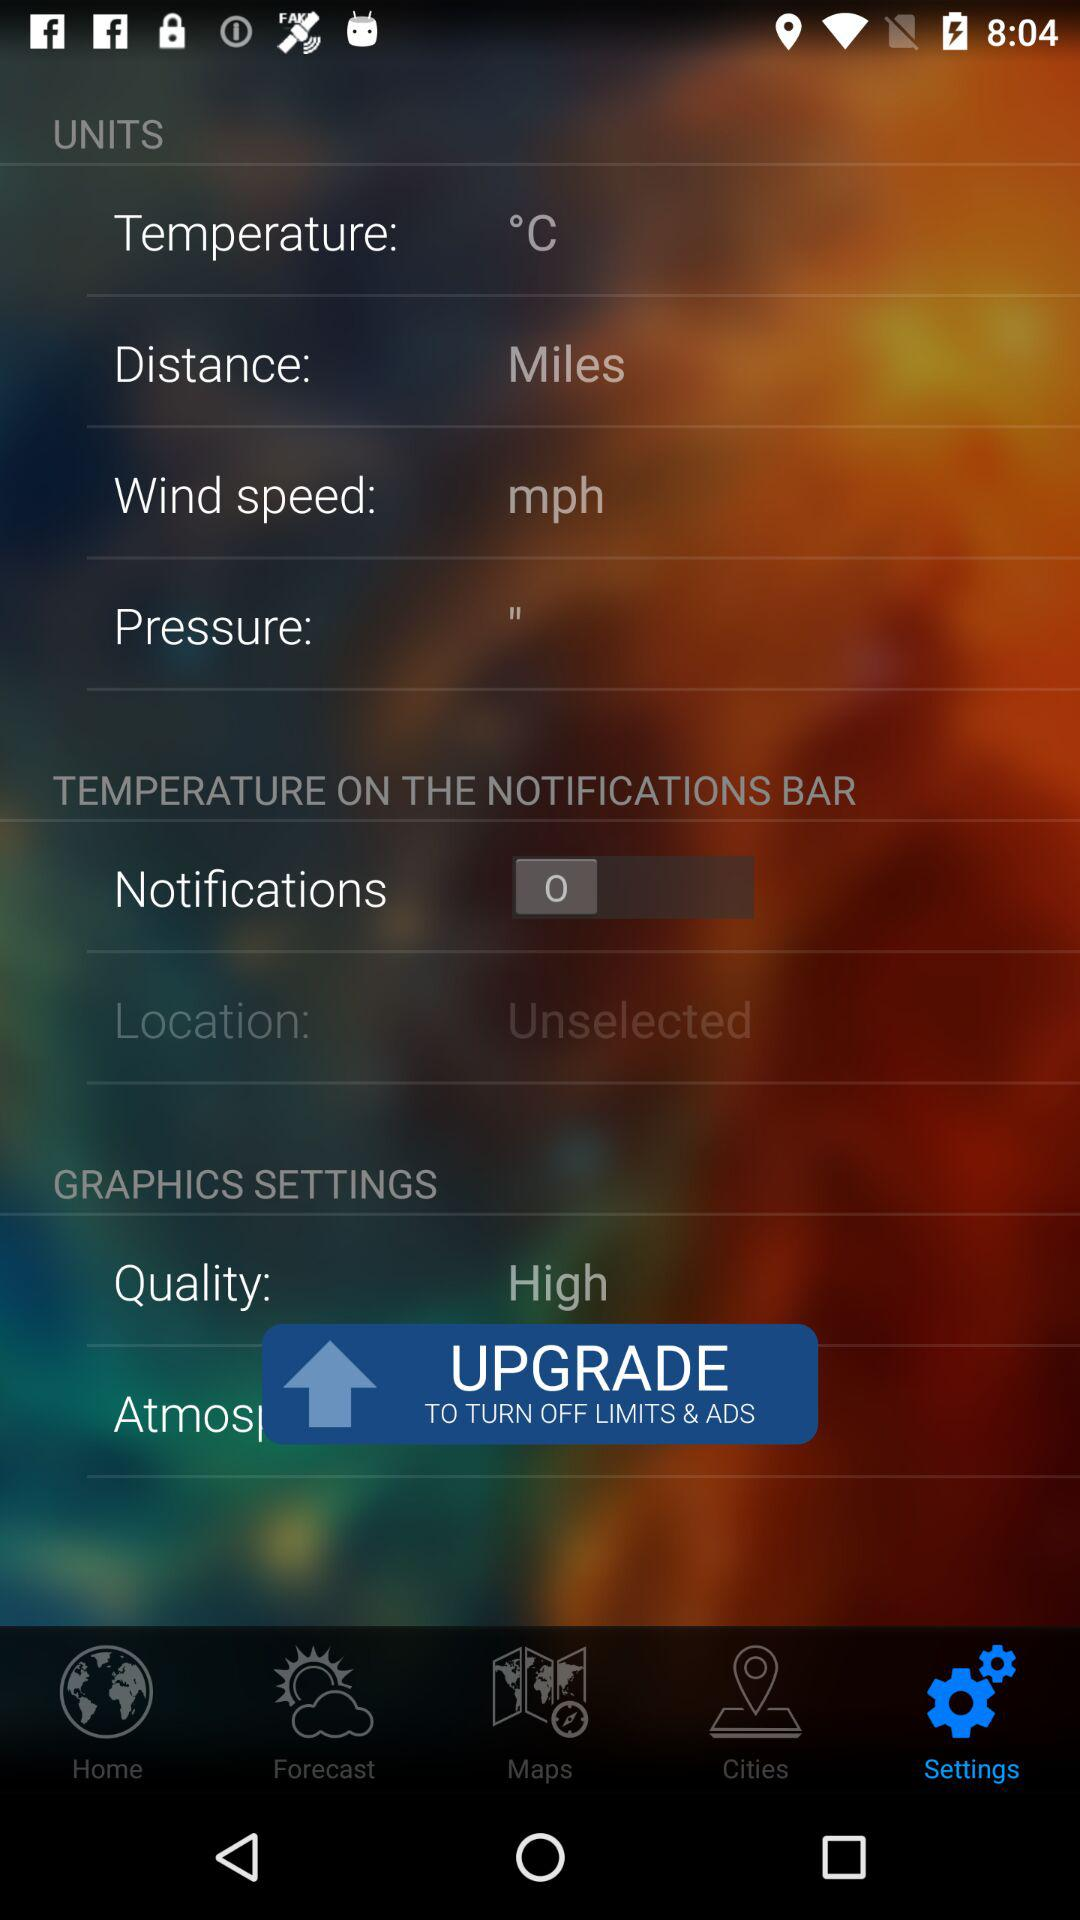Which unit is used to measure the wind speed? The used unit to measure the wind speed is mph. 